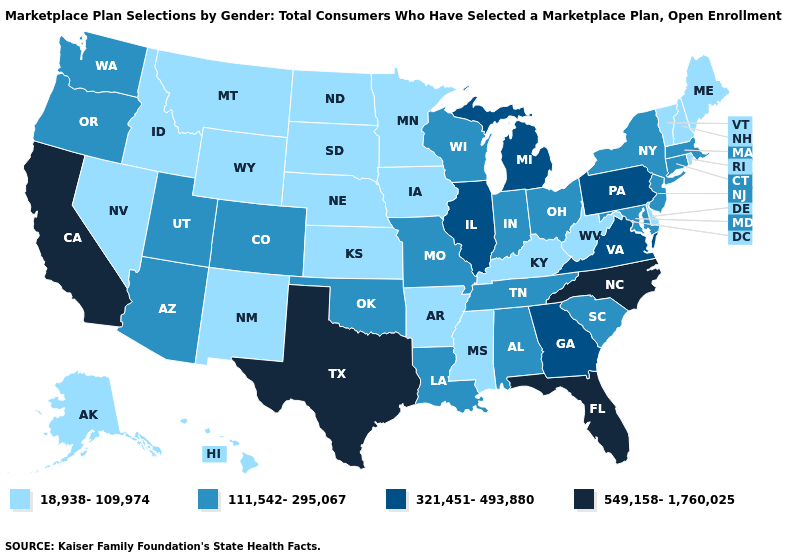Is the legend a continuous bar?
Be succinct. No. What is the lowest value in states that border Rhode Island?
Concise answer only. 111,542-295,067. Among the states that border North Dakota , which have the lowest value?
Be succinct. Minnesota, Montana, South Dakota. Name the states that have a value in the range 549,158-1,760,025?
Write a very short answer. California, Florida, North Carolina, Texas. Which states have the lowest value in the Northeast?
Write a very short answer. Maine, New Hampshire, Rhode Island, Vermont. Does Tennessee have the same value as Wyoming?
Concise answer only. No. How many symbols are there in the legend?
Keep it brief. 4. Does California have the highest value in the West?
Be succinct. Yes. What is the highest value in the Northeast ?
Keep it brief. 321,451-493,880. Does Wyoming have the same value as Georgia?
Give a very brief answer. No. What is the value of Iowa?
Give a very brief answer. 18,938-109,974. Which states have the highest value in the USA?
Quick response, please. California, Florida, North Carolina, Texas. What is the lowest value in the USA?
Give a very brief answer. 18,938-109,974. Which states have the lowest value in the USA?
Be succinct. Alaska, Arkansas, Delaware, Hawaii, Idaho, Iowa, Kansas, Kentucky, Maine, Minnesota, Mississippi, Montana, Nebraska, Nevada, New Hampshire, New Mexico, North Dakota, Rhode Island, South Dakota, Vermont, West Virginia, Wyoming. What is the lowest value in the USA?
Quick response, please. 18,938-109,974. 